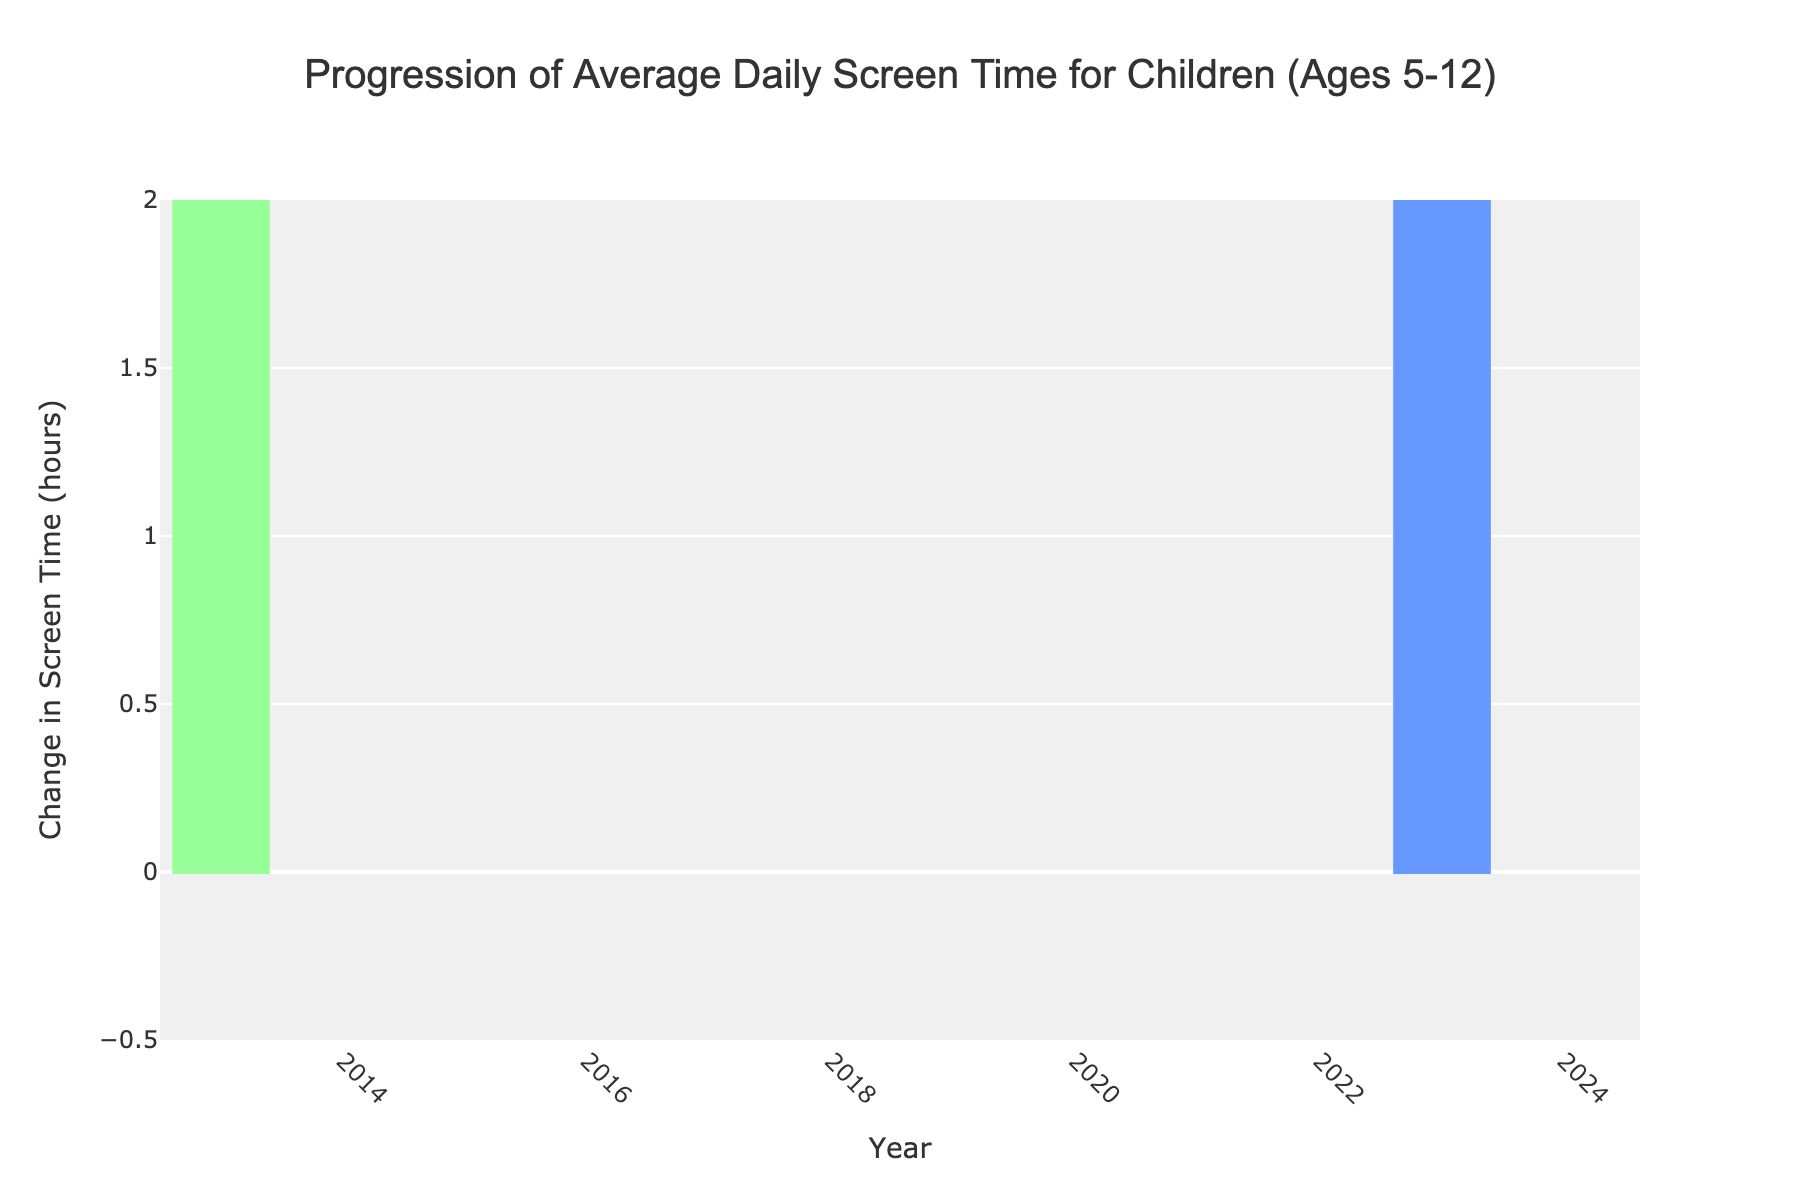What's the title of the figure? The title is displayed at the top of the figure and reads "Progression of Average Daily Screen Time for Children (Ages 5-12)"
Answer: Progression of Average Daily Screen Time for Children (Ages 5-12) What is the change in screen time in 2020? We can read from the data points corresponding to 2020; a green bar indicating an increase of 1.5 hours
Answer: 1.5 hours How does the screen time change from 2022 to 2023? The color of the bars for these years is red, indicating a decrease. The values show a decrease of 0.3 hours in 2022 and another decrease of 0.1 hours in 2023
Answer: It decreased by 0.1 hours What was the total screen time change by the end of the decade? The annotation near the last data point (2023) provides the total cumulative change over the decade, which is 6.7 hours
Answer: 6.7 hours Between which consecutive years did the screen time increase the most? By comparing the heights of the green bars, the largest increase is from 2019 to 2020 with a change of 1.5 hours
Answer: 2019 to 2020 How many times did the screen time decrease over the decade? By counting the number of red bars, we see decreases in 2022 and 2023
Answer: 2 times What was the cumulative screen time in 2019? By checking the cumulative value at the end of 2019 from the data table, we get 5.4 hours
Answer: 5.4 hours Which year had the smallest increase in screen time? By comparing the heights of the green bars, the smallest increase can be observed in 2021 with an increase of 0.2 hours
Answer: 2021 Was there any year with no change in screen time? By observing the figure, we don’t see any zero-level bars; all years have either positive or negative changes
Answer: No What is the cumulative screen time change by the year 2018? Summing the changes from 2013 to 2018 using cumulative values: 2.1 + 0.3 + 0.5 + 0.7 + 0.4 + 0.6 = 4.6 hours
Answer: 4.6 hours 